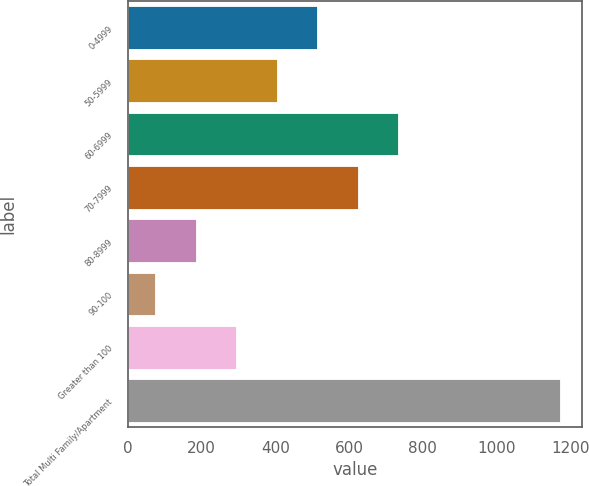<chart> <loc_0><loc_0><loc_500><loc_500><bar_chart><fcel>0-4999<fcel>50-5999<fcel>60-6999<fcel>70-7999<fcel>80-8999<fcel>90-100<fcel>Greater than 100<fcel>Total Multi Family/Apartment<nl><fcel>514.2<fcel>404.4<fcel>733.8<fcel>624<fcel>184.8<fcel>75<fcel>294.6<fcel>1173<nl></chart> 